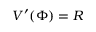<formula> <loc_0><loc_0><loc_500><loc_500>V ^ { \prime } ( \Phi ) = R</formula> 